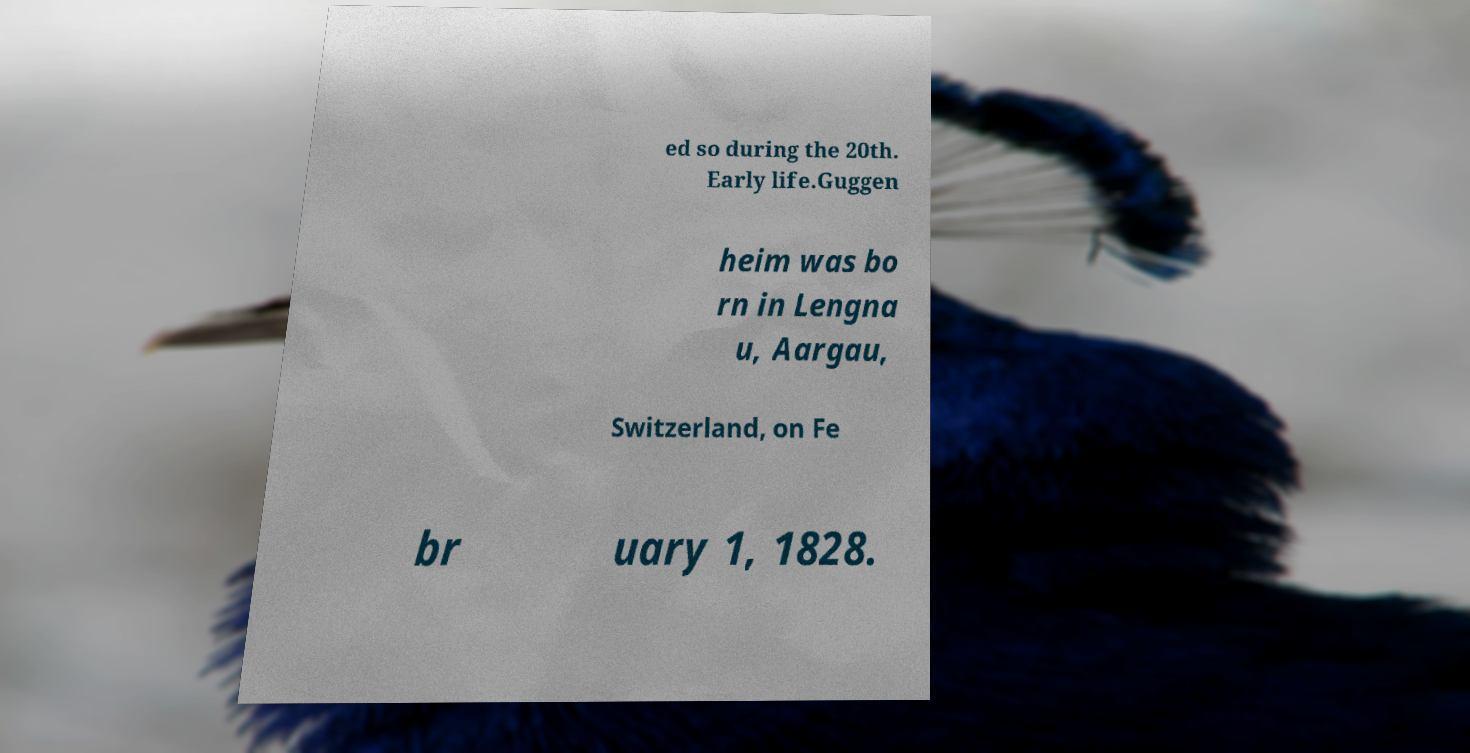Can you accurately transcribe the text from the provided image for me? ed so during the 20th. Early life.Guggen heim was bo rn in Lengna u, Aargau, Switzerland, on Fe br uary 1, 1828. 